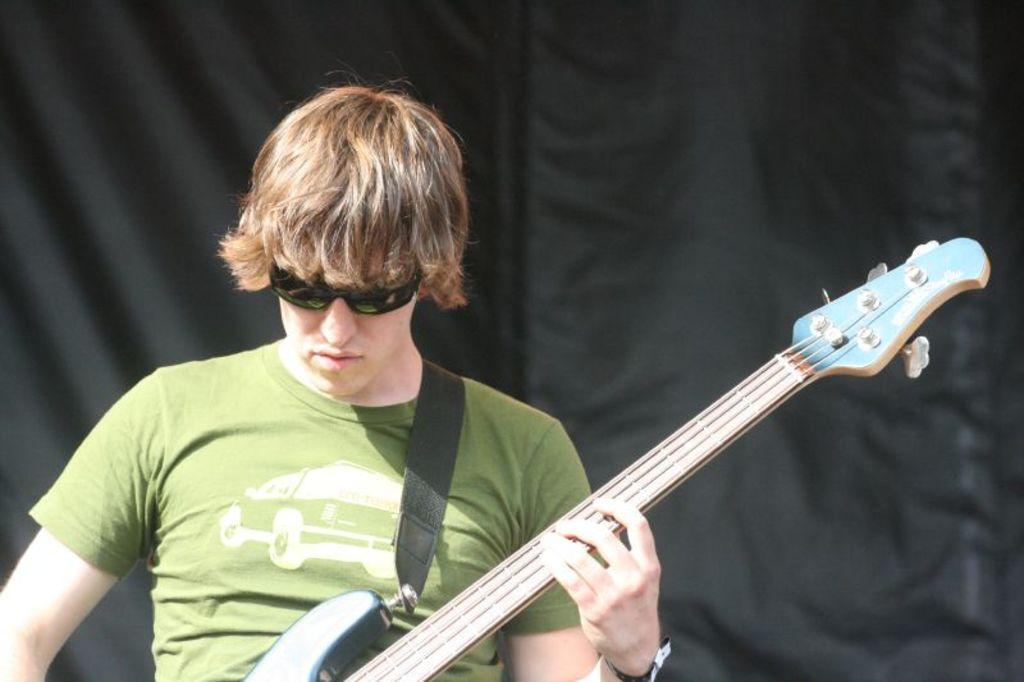Who is the main subject in the image? There is a man in the image. What is the man holding in the image? The man is holding a guitar. What accessory is the man wearing in the image? The man is wearing shades. What type of stew is the man cooking in the image? There is no stew present in the image; the man is holding a guitar. How many books can be seen on the shelf behind the man in the image? There is no shelf or books visible in the image; the man is the main subject. 